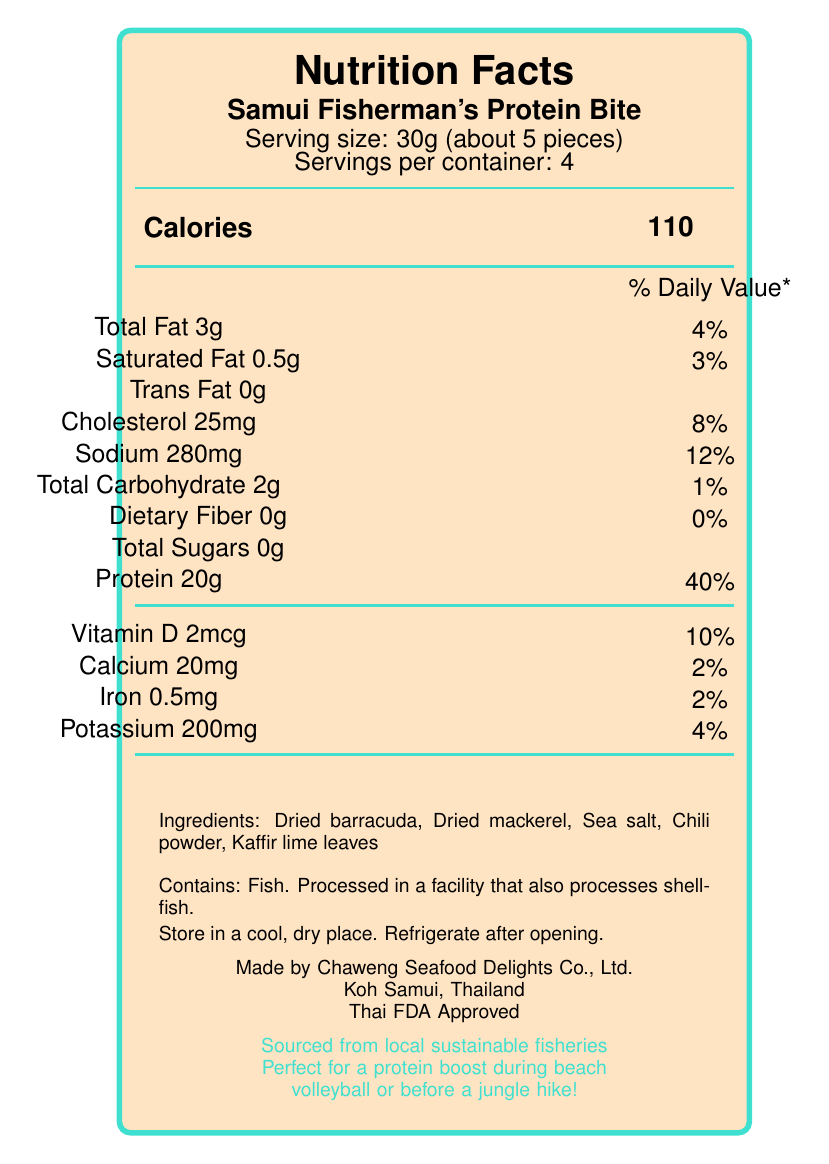what is the serving size? The serving size is mentioned under the product name, “Samui Fisherman's Protein Bite," indicating 30g and approximately 5 pieces.
Answer: 30g (about 5 pieces) how many servings are in one container? The number of servings per container is listed as "4" right below the serving size information.
Answer: 4 how many calories are in one serving? The number of calories per serving is listed next to the word “Calories” in bold text, stating "110".
Answer: 110 what percentage of daily value is the sodium content? The sodium content percentage is listed as "12%" next to "Sodium 280mg".
Answer: 12% what vitamins and minerals are included in this snack? Listed under the total sugars and protein are vitamin D, calcium, iron, and potassium along with their amounts and daily values.
Answer: Vitamin D, Calcium, Iron, Potassium what is the main ingredient of this product? A. Sea salt B. Dried barracuda C. Chili powder D. Kaffir lime leaves The ingredients listed first is "Dried barracuda", indicating it's the main ingredient.
Answer: B what is the protein content of one serving? The protein content per serving is listed as “Protein 20g” with a daily value of 40%.
Answer: 20g is this fish snack gluten-free? The document does not provide any information regarding the presence or absence of gluten.
Answer: Not enough information how much saturated fat does one serving contain? The saturated fat content per serving is listed as "0.5g".
Answer: 0.5g what is the amount of vitamin D in this fish snack? The amount of vitamin D is listed as "2mcg" with a daily value of 10%.
Answer: 2mcg what are the storage instructions for this product? The storage instructions are listed towards the end of the document, specifying to "Store in a cool, dry place" and to "Refrigerate after opening."
Answer: Store in a cool, dry place. Refrigerate after opening. does this snack contain any allergens? The allergen information specifies that it contains fish and that it is processed in a facility that also processes shellfish.
Answer: Yes which company manufactures this product? A. Koh Samui Snacks Ltd. B. Chaweng Seafood Delights Co., Ltd. C. Fisherman's Friend D. Thai FDA The manufacturer listed is "Chaweng Seafood Delights Co., Ltd."
Answer: B how should this snack be used for an outdoor activity? The usage suggestion mentions it's perfect for a protein boost during beach volleyball or before a jungle hike, reflecting its effectiveness for outdoor activities.
Answer: Perfect for a protein boost during beach volleyball or before a jungle hike. is this product FDA approved? The document mentions “Thai FDA Approved” indicating it is approved by the Thai FDA.
Answer: Yes describe the main idea or purpose of this product. This product provides high protein content (20g per serving) and is specifically marketed towards being a convenient, nutritious option perfect for outdoor activities. It lists nutritional facts, ingredients, allergen information, and storage guidelines while emphasizing its local and sustainable sourcing.
Answer: The Samui Fisherman's Protein Bite is a high-protein fish snack designed for individuals seeking convenient and nutritious food options, especially beneficial for outdoor activities such as beach volleyball or jungle hikes. The snack contains a variety of nutritious ingredients like dried barracuda and mackerel, and it is sourced from local sustainable fisheries. what is the total carbohydrate content in one serving? The total carbohydrate content is listed as "2g" with a daily value of 1%.
Answer: 2g 